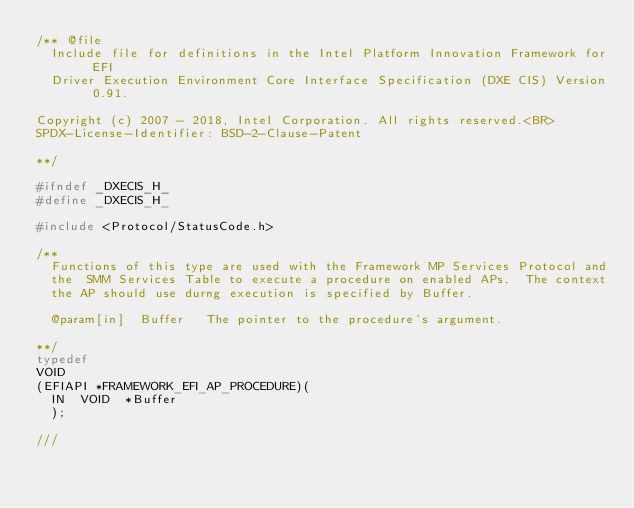Convert code to text. <code><loc_0><loc_0><loc_500><loc_500><_C_>/** @file
  Include file for definitions in the Intel Platform Innovation Framework for EFI
  Driver Execution Environment Core Interface Specification (DXE CIS) Version 0.91.

Copyright (c) 2007 - 2018, Intel Corporation. All rights reserved.<BR>
SPDX-License-Identifier: BSD-2-Clause-Patent

**/

#ifndef _DXECIS_H_
#define _DXECIS_H_

#include <Protocol/StatusCode.h>

/**
  Functions of this type are used with the Framework MP Services Protocol and
  the  SMM Services Table to execute a procedure on enabled APs.  The context
  the AP should use durng execution is specified by Buffer.

  @param[in]  Buffer   The pointer to the procedure's argument.

**/
typedef
VOID
(EFIAPI *FRAMEWORK_EFI_AP_PROCEDURE)(
  IN  VOID  *Buffer
  );

///</code> 